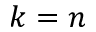<formula> <loc_0><loc_0><loc_500><loc_500>k = n</formula> 